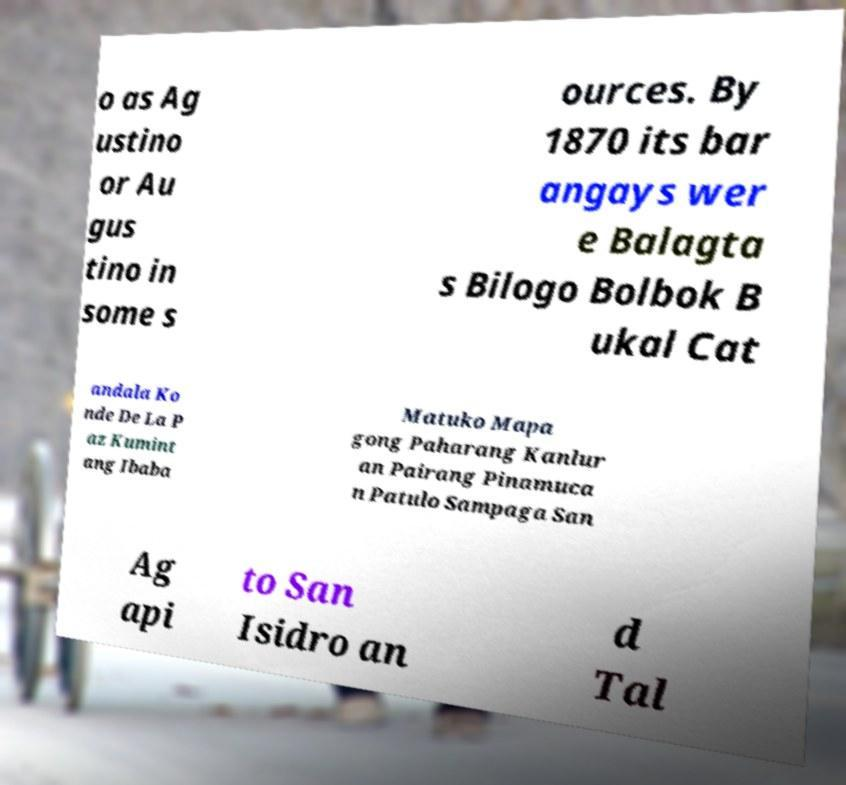Could you extract and type out the text from this image? o as Ag ustino or Au gus tino in some s ources. By 1870 its bar angays wer e Balagta s Bilogo Bolbok B ukal Cat andala Ko nde De La P az Kumint ang Ibaba Matuko Mapa gong Paharang Kanlur an Pairang Pinamuca n Patulo Sampaga San Ag api to San Isidro an d Tal 